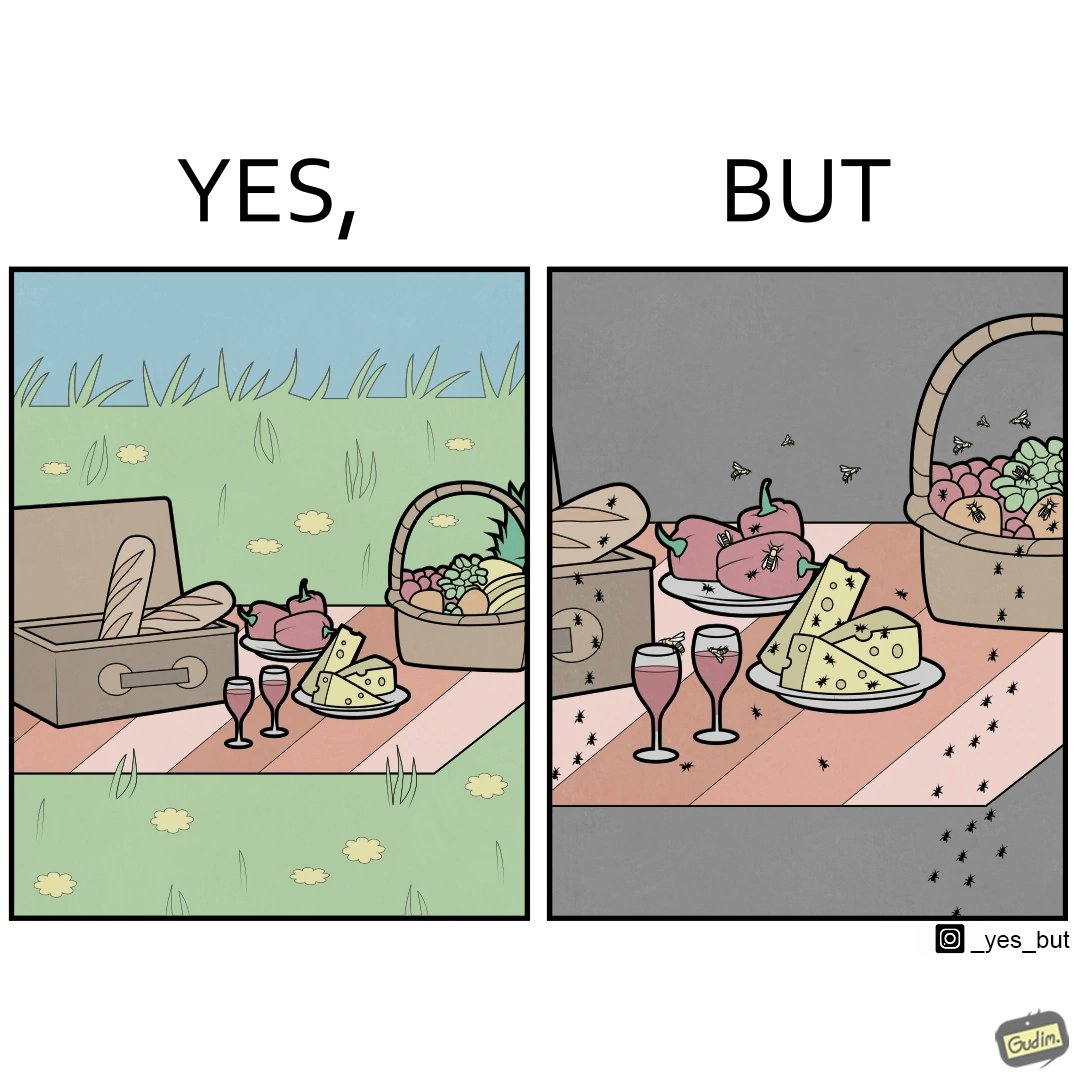Is this image satirical or non-satirical? Yes, this image is satirical. 